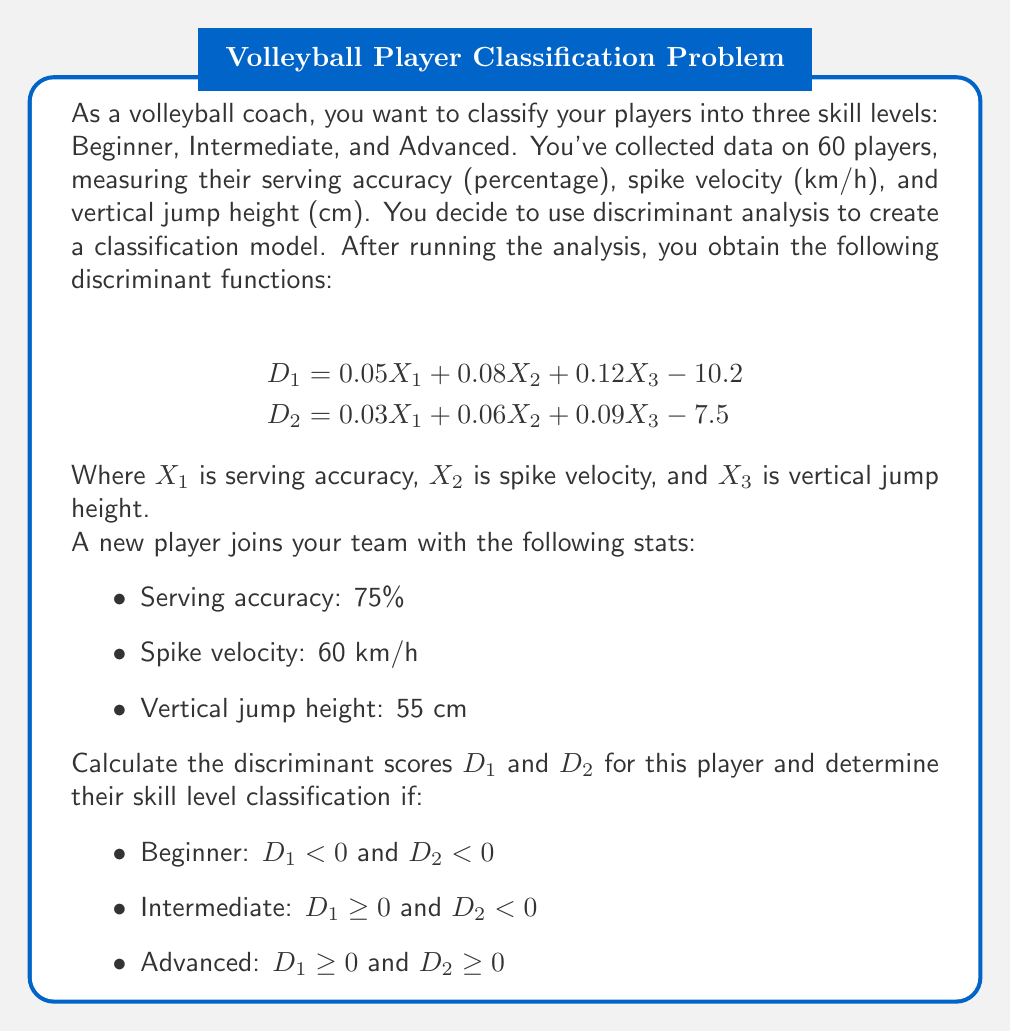Teach me how to tackle this problem. To solve this problem, we need to follow these steps:

1. Substitute the player's stats into the discriminant functions.
2. Calculate the discriminant scores $D_1$ and $D_2$.
3. Use the classification rules to determine the player's skill level.

Step 1: Substituting the player's stats into the discriminant functions

For $D_1$:
$$\begin{align}
D_1 &= 0.05X_1 + 0.08X_2 + 0.12X_3 - 10.2 \\
&= 0.05(75) + 0.08(60) + 0.12(55) - 10.2
\end{align}$$

For $D_2$:
$$\begin{align}
D_2 &= 0.03X_1 + 0.06X_2 + 0.09X_3 - 7.5 \\
&= 0.03(75) + 0.06(60) + 0.09(55) - 7.5
\end{align}$$

Step 2: Calculating the discriminant scores

For $D_1$:
$$\begin{align}
D_1 &= 0.05(75) + 0.08(60) + 0.12(55) - 10.2 \\
&= 3.75 + 4.8 + 6.6 - 10.2 \\
&= 4.95
\end{align}$$

For $D_2$:
$$\begin{align}
D_2 &= 0.03(75) + 0.06(60) + 0.09(55) - 7.5 \\
&= 2.25 + 3.6 + 4.95 - 7.5 \\
&= 3.3
\end{align}$$

Step 3: Determining the player's skill level

According to the classification rules:
- Beginner: $D_1 < 0$ and $D_2 < 0$
- Intermediate: $D_1 \geq 0$ and $D_2 < 0$
- Advanced: $D_1 \geq 0$ and $D_2 \geq 0$

We found that $D_1 = 4.95$ and $D_2 = 3.3$. Both $D_1$ and $D_2$ are greater than or equal to 0, which satisfies the condition for the Advanced skill level.
Answer: The player's discriminant scores are $D_1 = 4.95$ and $D_2 = 3.3$. Based on these scores and the given classification rules, the player is classified as Advanced. 